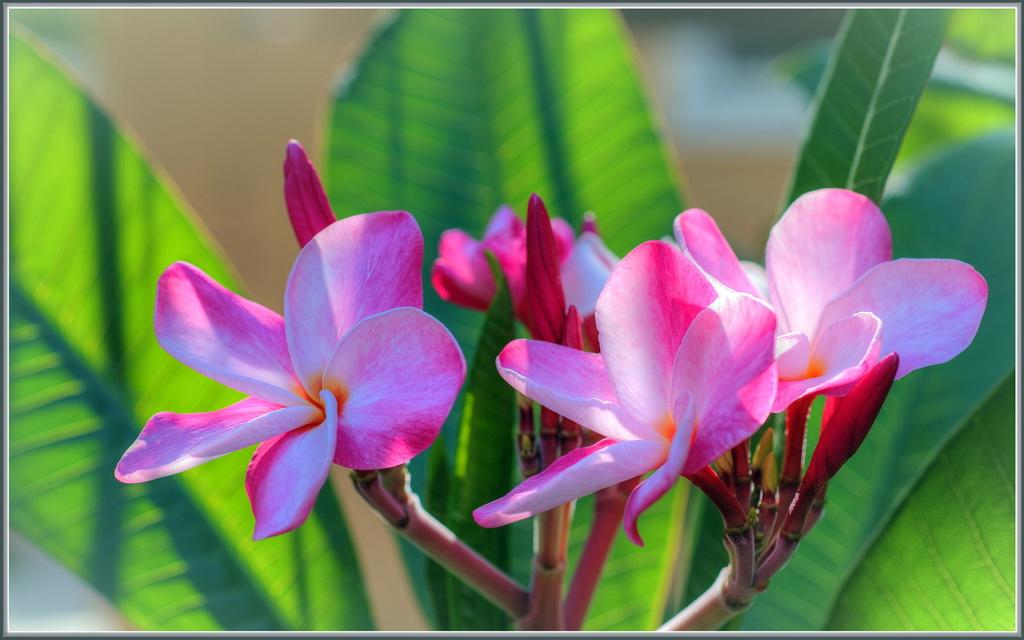What type of plants can be seen in the image? There are flowers in the image. What else can be seen in the background of the image? There are leaves in the background of the image. What type of box can be seen on the island in the image? There is no box or island present in the image; it features flowers and leaves. What type of cracker is being used to feed the birds in the image? There are no birds or crackers present in the image. 